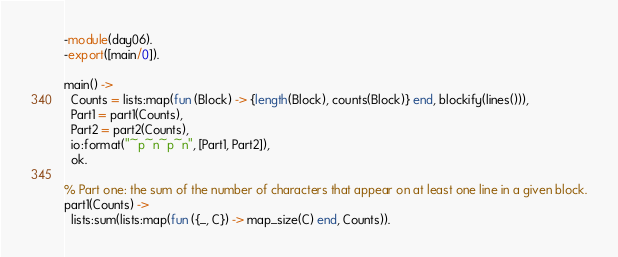<code> <loc_0><loc_0><loc_500><loc_500><_Erlang_>-module(day06).
-export([main/0]).

main() ->
  Counts = lists:map(fun (Block) -> {length(Block), counts(Block)} end, blockify(lines())),
  Part1 = part1(Counts),
  Part2 = part2(Counts),
  io:format("~p~n~p~n", [Part1, Part2]),
  ok.

% Part one: the sum of the number of characters that appear on at least one line in a given block.
part1(Counts) ->
  lists:sum(lists:map(fun ({_, C}) -> map_size(C) end, Counts)).
</code> 